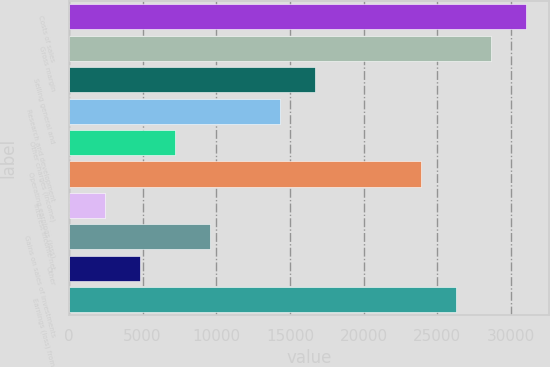<chart> <loc_0><loc_0><loc_500><loc_500><bar_chart><fcel>Costs of sales<fcel>Gross margin<fcel>Selling general and<fcel>Research and development<fcel>Other charges (income)<fcel>Operating earnings (loss)<fcel>Interest income net<fcel>Gains on sales of investments<fcel>Other<fcel>Earnings (loss) from<nl><fcel>31027.6<fcel>28645.4<fcel>16734.4<fcel>14352.2<fcel>7205.6<fcel>23881<fcel>2441.2<fcel>9587.8<fcel>4823.4<fcel>26263.2<nl></chart> 